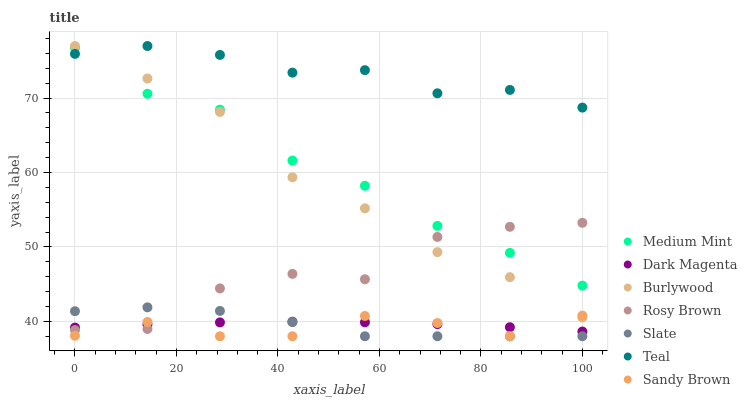Does Sandy Brown have the minimum area under the curve?
Answer yes or no. Yes. Does Teal have the maximum area under the curve?
Answer yes or no. Yes. Does Dark Magenta have the minimum area under the curve?
Answer yes or no. No. Does Dark Magenta have the maximum area under the curve?
Answer yes or no. No. Is Dark Magenta the smoothest?
Answer yes or no. Yes. Is Rosy Brown the roughest?
Answer yes or no. Yes. Is Burlywood the smoothest?
Answer yes or no. No. Is Burlywood the roughest?
Answer yes or no. No. Does Slate have the lowest value?
Answer yes or no. Yes. Does Dark Magenta have the lowest value?
Answer yes or no. No. Does Teal have the highest value?
Answer yes or no. Yes. Does Dark Magenta have the highest value?
Answer yes or no. No. Is Dark Magenta less than Medium Mint?
Answer yes or no. Yes. Is Medium Mint greater than Sandy Brown?
Answer yes or no. Yes. Does Burlywood intersect Teal?
Answer yes or no. Yes. Is Burlywood less than Teal?
Answer yes or no. No. Is Burlywood greater than Teal?
Answer yes or no. No. Does Dark Magenta intersect Medium Mint?
Answer yes or no. No. 